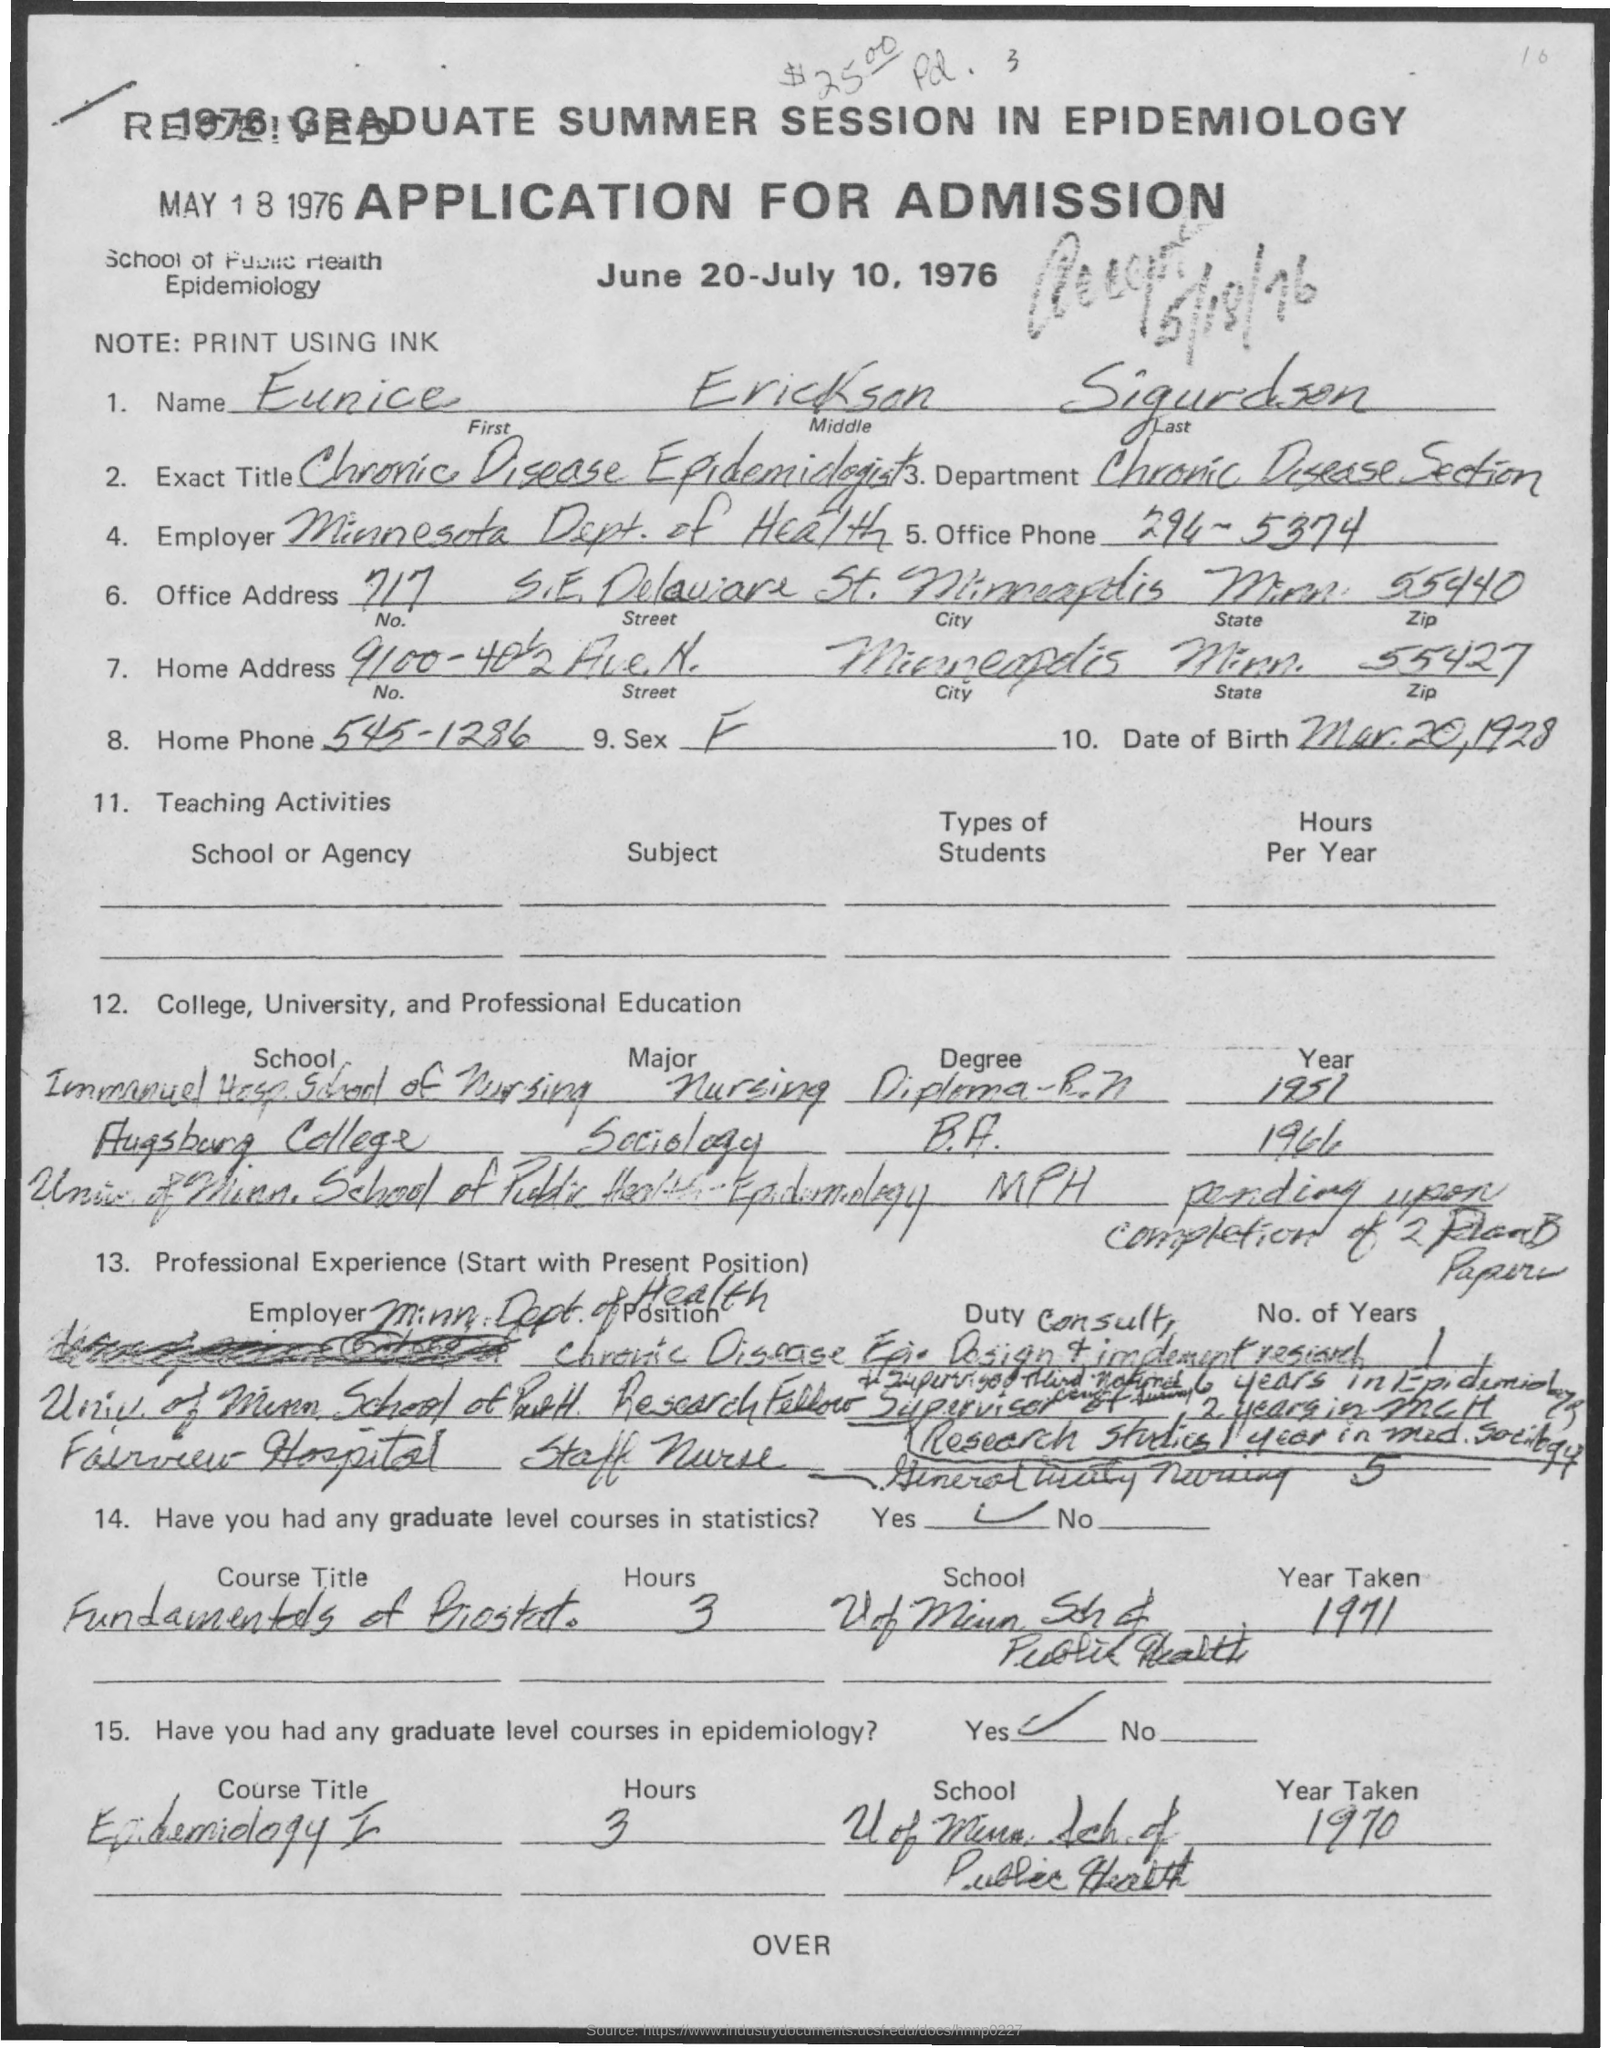List a handful of essential elements in this visual. The office phone number mentioned in the application is 294-5374. The zipcode mentioned in the home address is 55427. The first name of the applicant is EUNICE. Eunice Erickson Sigurdson works in the Chronic Disease Section. Eunice Erickson Sigurdson is a chronic disease epidemiologist. 